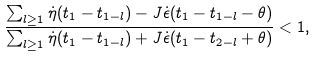Convert formula to latex. <formula><loc_0><loc_0><loc_500><loc_500>\frac { \sum _ { l \geq 1 } \dot { \eta } ( t _ { 1 } - t _ { 1 - l } ) - J \dot { \epsilon } ( t _ { 1 } - t _ { 1 - l } - \theta ) } { \sum _ { l \geq 1 } \dot { \eta } ( t _ { 1 } - t _ { 1 - l } ) + J \dot { \epsilon } ( t _ { 1 } - t _ { 2 - l } + \theta ) } < 1 ,</formula> 